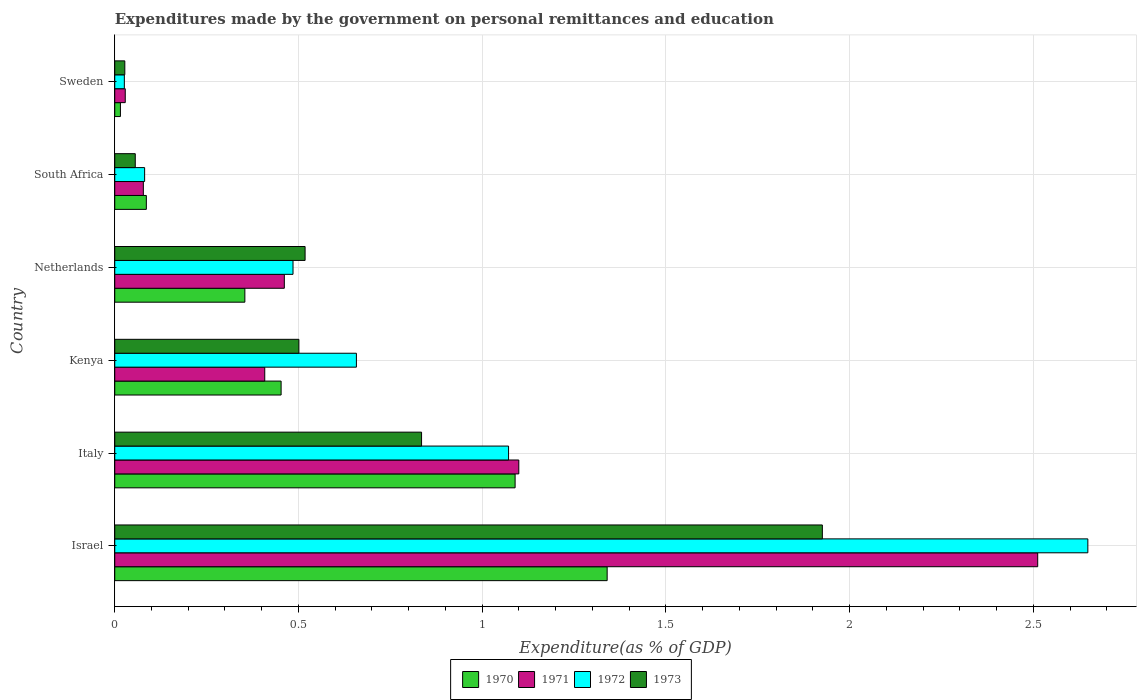How many different coloured bars are there?
Offer a very short reply. 4. Are the number of bars per tick equal to the number of legend labels?
Your answer should be very brief. Yes. Are the number of bars on each tick of the Y-axis equal?
Provide a short and direct response. Yes. How many bars are there on the 1st tick from the top?
Make the answer very short. 4. How many bars are there on the 3rd tick from the bottom?
Provide a short and direct response. 4. What is the label of the 6th group of bars from the top?
Give a very brief answer. Israel. In how many cases, is the number of bars for a given country not equal to the number of legend labels?
Keep it short and to the point. 0. What is the expenditures made by the government on personal remittances and education in 1970 in Italy?
Your answer should be very brief. 1.09. Across all countries, what is the maximum expenditures made by the government on personal remittances and education in 1973?
Provide a short and direct response. 1.93. Across all countries, what is the minimum expenditures made by the government on personal remittances and education in 1972?
Offer a terse response. 0.03. In which country was the expenditures made by the government on personal remittances and education in 1972 minimum?
Offer a terse response. Sweden. What is the total expenditures made by the government on personal remittances and education in 1971 in the graph?
Offer a terse response. 4.59. What is the difference between the expenditures made by the government on personal remittances and education in 1972 in Israel and that in Italy?
Make the answer very short. 1.58. What is the difference between the expenditures made by the government on personal remittances and education in 1970 in Sweden and the expenditures made by the government on personal remittances and education in 1973 in Netherlands?
Ensure brevity in your answer.  -0.5. What is the average expenditures made by the government on personal remittances and education in 1973 per country?
Offer a very short reply. 0.64. What is the difference between the expenditures made by the government on personal remittances and education in 1971 and expenditures made by the government on personal remittances and education in 1973 in Netherlands?
Your answer should be very brief. -0.06. What is the ratio of the expenditures made by the government on personal remittances and education in 1971 in Italy to that in Netherlands?
Ensure brevity in your answer.  2.38. What is the difference between the highest and the second highest expenditures made by the government on personal remittances and education in 1972?
Offer a terse response. 1.58. What is the difference between the highest and the lowest expenditures made by the government on personal remittances and education in 1972?
Provide a succinct answer. 2.62. In how many countries, is the expenditures made by the government on personal remittances and education in 1972 greater than the average expenditures made by the government on personal remittances and education in 1972 taken over all countries?
Keep it short and to the point. 2. Is the sum of the expenditures made by the government on personal remittances and education in 1972 in Israel and South Africa greater than the maximum expenditures made by the government on personal remittances and education in 1973 across all countries?
Offer a very short reply. Yes. What does the 1st bar from the top in Israel represents?
Offer a terse response. 1973. How many countries are there in the graph?
Your response must be concise. 6. Are the values on the major ticks of X-axis written in scientific E-notation?
Offer a terse response. No. Where does the legend appear in the graph?
Your answer should be compact. Bottom center. How many legend labels are there?
Give a very brief answer. 4. How are the legend labels stacked?
Your answer should be very brief. Horizontal. What is the title of the graph?
Ensure brevity in your answer.  Expenditures made by the government on personal remittances and education. Does "1998" appear as one of the legend labels in the graph?
Offer a very short reply. No. What is the label or title of the X-axis?
Ensure brevity in your answer.  Expenditure(as % of GDP). What is the Expenditure(as % of GDP) of 1970 in Israel?
Provide a succinct answer. 1.34. What is the Expenditure(as % of GDP) in 1971 in Israel?
Offer a terse response. 2.51. What is the Expenditure(as % of GDP) of 1972 in Israel?
Ensure brevity in your answer.  2.65. What is the Expenditure(as % of GDP) in 1973 in Israel?
Provide a succinct answer. 1.93. What is the Expenditure(as % of GDP) in 1970 in Italy?
Give a very brief answer. 1.09. What is the Expenditure(as % of GDP) of 1971 in Italy?
Make the answer very short. 1.1. What is the Expenditure(as % of GDP) of 1972 in Italy?
Offer a very short reply. 1.07. What is the Expenditure(as % of GDP) of 1973 in Italy?
Your answer should be compact. 0.84. What is the Expenditure(as % of GDP) in 1970 in Kenya?
Your response must be concise. 0.45. What is the Expenditure(as % of GDP) in 1971 in Kenya?
Ensure brevity in your answer.  0.41. What is the Expenditure(as % of GDP) of 1972 in Kenya?
Your answer should be compact. 0.66. What is the Expenditure(as % of GDP) of 1973 in Kenya?
Keep it short and to the point. 0.5. What is the Expenditure(as % of GDP) in 1970 in Netherlands?
Ensure brevity in your answer.  0.35. What is the Expenditure(as % of GDP) in 1971 in Netherlands?
Make the answer very short. 0.46. What is the Expenditure(as % of GDP) in 1972 in Netherlands?
Offer a terse response. 0.49. What is the Expenditure(as % of GDP) in 1973 in Netherlands?
Your response must be concise. 0.52. What is the Expenditure(as % of GDP) of 1970 in South Africa?
Offer a terse response. 0.09. What is the Expenditure(as % of GDP) of 1971 in South Africa?
Offer a very short reply. 0.08. What is the Expenditure(as % of GDP) of 1972 in South Africa?
Provide a short and direct response. 0.08. What is the Expenditure(as % of GDP) in 1973 in South Africa?
Keep it short and to the point. 0.06. What is the Expenditure(as % of GDP) of 1970 in Sweden?
Make the answer very short. 0.02. What is the Expenditure(as % of GDP) in 1971 in Sweden?
Your response must be concise. 0.03. What is the Expenditure(as % of GDP) of 1972 in Sweden?
Offer a terse response. 0.03. What is the Expenditure(as % of GDP) of 1973 in Sweden?
Give a very brief answer. 0.03. Across all countries, what is the maximum Expenditure(as % of GDP) in 1970?
Provide a short and direct response. 1.34. Across all countries, what is the maximum Expenditure(as % of GDP) of 1971?
Offer a terse response. 2.51. Across all countries, what is the maximum Expenditure(as % of GDP) of 1972?
Keep it short and to the point. 2.65. Across all countries, what is the maximum Expenditure(as % of GDP) of 1973?
Your answer should be very brief. 1.93. Across all countries, what is the minimum Expenditure(as % of GDP) in 1970?
Give a very brief answer. 0.02. Across all countries, what is the minimum Expenditure(as % of GDP) of 1971?
Give a very brief answer. 0.03. Across all countries, what is the minimum Expenditure(as % of GDP) of 1972?
Ensure brevity in your answer.  0.03. Across all countries, what is the minimum Expenditure(as % of GDP) in 1973?
Your answer should be compact. 0.03. What is the total Expenditure(as % of GDP) in 1970 in the graph?
Offer a very short reply. 3.34. What is the total Expenditure(as % of GDP) of 1971 in the graph?
Make the answer very short. 4.59. What is the total Expenditure(as % of GDP) in 1972 in the graph?
Your answer should be compact. 4.97. What is the total Expenditure(as % of GDP) in 1973 in the graph?
Your response must be concise. 3.86. What is the difference between the Expenditure(as % of GDP) in 1970 in Israel and that in Italy?
Provide a succinct answer. 0.25. What is the difference between the Expenditure(as % of GDP) in 1971 in Israel and that in Italy?
Offer a very short reply. 1.41. What is the difference between the Expenditure(as % of GDP) of 1972 in Israel and that in Italy?
Give a very brief answer. 1.58. What is the difference between the Expenditure(as % of GDP) in 1970 in Israel and that in Kenya?
Offer a very short reply. 0.89. What is the difference between the Expenditure(as % of GDP) in 1971 in Israel and that in Kenya?
Provide a short and direct response. 2.1. What is the difference between the Expenditure(as % of GDP) in 1972 in Israel and that in Kenya?
Make the answer very short. 1.99. What is the difference between the Expenditure(as % of GDP) in 1973 in Israel and that in Kenya?
Your response must be concise. 1.42. What is the difference between the Expenditure(as % of GDP) in 1970 in Israel and that in Netherlands?
Make the answer very short. 0.99. What is the difference between the Expenditure(as % of GDP) of 1971 in Israel and that in Netherlands?
Provide a succinct answer. 2.05. What is the difference between the Expenditure(as % of GDP) of 1972 in Israel and that in Netherlands?
Provide a succinct answer. 2.16. What is the difference between the Expenditure(as % of GDP) of 1973 in Israel and that in Netherlands?
Make the answer very short. 1.41. What is the difference between the Expenditure(as % of GDP) of 1970 in Israel and that in South Africa?
Ensure brevity in your answer.  1.25. What is the difference between the Expenditure(as % of GDP) of 1971 in Israel and that in South Africa?
Your response must be concise. 2.43. What is the difference between the Expenditure(as % of GDP) in 1972 in Israel and that in South Africa?
Provide a short and direct response. 2.57. What is the difference between the Expenditure(as % of GDP) of 1973 in Israel and that in South Africa?
Offer a very short reply. 1.87. What is the difference between the Expenditure(as % of GDP) of 1970 in Israel and that in Sweden?
Offer a terse response. 1.32. What is the difference between the Expenditure(as % of GDP) of 1971 in Israel and that in Sweden?
Offer a terse response. 2.48. What is the difference between the Expenditure(as % of GDP) of 1972 in Israel and that in Sweden?
Your answer should be very brief. 2.62. What is the difference between the Expenditure(as % of GDP) in 1973 in Israel and that in Sweden?
Provide a short and direct response. 1.9. What is the difference between the Expenditure(as % of GDP) in 1970 in Italy and that in Kenya?
Provide a short and direct response. 0.64. What is the difference between the Expenditure(as % of GDP) in 1971 in Italy and that in Kenya?
Your answer should be compact. 0.69. What is the difference between the Expenditure(as % of GDP) of 1972 in Italy and that in Kenya?
Provide a short and direct response. 0.41. What is the difference between the Expenditure(as % of GDP) in 1973 in Italy and that in Kenya?
Keep it short and to the point. 0.33. What is the difference between the Expenditure(as % of GDP) of 1970 in Italy and that in Netherlands?
Your answer should be very brief. 0.74. What is the difference between the Expenditure(as % of GDP) in 1971 in Italy and that in Netherlands?
Provide a succinct answer. 0.64. What is the difference between the Expenditure(as % of GDP) in 1972 in Italy and that in Netherlands?
Provide a succinct answer. 0.59. What is the difference between the Expenditure(as % of GDP) in 1973 in Italy and that in Netherlands?
Keep it short and to the point. 0.32. What is the difference between the Expenditure(as % of GDP) in 1971 in Italy and that in South Africa?
Give a very brief answer. 1.02. What is the difference between the Expenditure(as % of GDP) of 1972 in Italy and that in South Africa?
Your answer should be compact. 0.99. What is the difference between the Expenditure(as % of GDP) of 1973 in Italy and that in South Africa?
Your answer should be very brief. 0.78. What is the difference between the Expenditure(as % of GDP) in 1970 in Italy and that in Sweden?
Your answer should be very brief. 1.07. What is the difference between the Expenditure(as % of GDP) in 1971 in Italy and that in Sweden?
Provide a succinct answer. 1.07. What is the difference between the Expenditure(as % of GDP) of 1972 in Italy and that in Sweden?
Make the answer very short. 1.05. What is the difference between the Expenditure(as % of GDP) in 1973 in Italy and that in Sweden?
Offer a terse response. 0.81. What is the difference between the Expenditure(as % of GDP) of 1970 in Kenya and that in Netherlands?
Provide a short and direct response. 0.1. What is the difference between the Expenditure(as % of GDP) of 1971 in Kenya and that in Netherlands?
Your answer should be very brief. -0.05. What is the difference between the Expenditure(as % of GDP) of 1972 in Kenya and that in Netherlands?
Your response must be concise. 0.17. What is the difference between the Expenditure(as % of GDP) in 1973 in Kenya and that in Netherlands?
Provide a succinct answer. -0.02. What is the difference between the Expenditure(as % of GDP) in 1970 in Kenya and that in South Africa?
Provide a short and direct response. 0.37. What is the difference between the Expenditure(as % of GDP) in 1971 in Kenya and that in South Africa?
Your answer should be very brief. 0.33. What is the difference between the Expenditure(as % of GDP) of 1972 in Kenya and that in South Africa?
Provide a succinct answer. 0.58. What is the difference between the Expenditure(as % of GDP) of 1973 in Kenya and that in South Africa?
Provide a succinct answer. 0.45. What is the difference between the Expenditure(as % of GDP) of 1970 in Kenya and that in Sweden?
Provide a succinct answer. 0.44. What is the difference between the Expenditure(as % of GDP) of 1971 in Kenya and that in Sweden?
Offer a terse response. 0.38. What is the difference between the Expenditure(as % of GDP) in 1972 in Kenya and that in Sweden?
Offer a terse response. 0.63. What is the difference between the Expenditure(as % of GDP) in 1973 in Kenya and that in Sweden?
Provide a succinct answer. 0.47. What is the difference between the Expenditure(as % of GDP) in 1970 in Netherlands and that in South Africa?
Give a very brief answer. 0.27. What is the difference between the Expenditure(as % of GDP) in 1971 in Netherlands and that in South Africa?
Make the answer very short. 0.38. What is the difference between the Expenditure(as % of GDP) in 1972 in Netherlands and that in South Africa?
Provide a short and direct response. 0.4. What is the difference between the Expenditure(as % of GDP) of 1973 in Netherlands and that in South Africa?
Keep it short and to the point. 0.46. What is the difference between the Expenditure(as % of GDP) in 1970 in Netherlands and that in Sweden?
Your response must be concise. 0.34. What is the difference between the Expenditure(as % of GDP) of 1971 in Netherlands and that in Sweden?
Your response must be concise. 0.43. What is the difference between the Expenditure(as % of GDP) in 1972 in Netherlands and that in Sweden?
Make the answer very short. 0.46. What is the difference between the Expenditure(as % of GDP) in 1973 in Netherlands and that in Sweden?
Offer a terse response. 0.49. What is the difference between the Expenditure(as % of GDP) in 1970 in South Africa and that in Sweden?
Your answer should be very brief. 0.07. What is the difference between the Expenditure(as % of GDP) of 1971 in South Africa and that in Sweden?
Your answer should be very brief. 0.05. What is the difference between the Expenditure(as % of GDP) in 1972 in South Africa and that in Sweden?
Keep it short and to the point. 0.06. What is the difference between the Expenditure(as % of GDP) of 1973 in South Africa and that in Sweden?
Your answer should be very brief. 0.03. What is the difference between the Expenditure(as % of GDP) of 1970 in Israel and the Expenditure(as % of GDP) of 1971 in Italy?
Offer a very short reply. 0.24. What is the difference between the Expenditure(as % of GDP) in 1970 in Israel and the Expenditure(as % of GDP) in 1972 in Italy?
Make the answer very short. 0.27. What is the difference between the Expenditure(as % of GDP) in 1970 in Israel and the Expenditure(as % of GDP) in 1973 in Italy?
Provide a succinct answer. 0.51. What is the difference between the Expenditure(as % of GDP) of 1971 in Israel and the Expenditure(as % of GDP) of 1972 in Italy?
Your answer should be very brief. 1.44. What is the difference between the Expenditure(as % of GDP) in 1971 in Israel and the Expenditure(as % of GDP) in 1973 in Italy?
Your answer should be compact. 1.68. What is the difference between the Expenditure(as % of GDP) in 1972 in Israel and the Expenditure(as % of GDP) in 1973 in Italy?
Your answer should be very brief. 1.81. What is the difference between the Expenditure(as % of GDP) in 1970 in Israel and the Expenditure(as % of GDP) in 1971 in Kenya?
Provide a short and direct response. 0.93. What is the difference between the Expenditure(as % of GDP) of 1970 in Israel and the Expenditure(as % of GDP) of 1972 in Kenya?
Offer a terse response. 0.68. What is the difference between the Expenditure(as % of GDP) in 1970 in Israel and the Expenditure(as % of GDP) in 1973 in Kenya?
Offer a very short reply. 0.84. What is the difference between the Expenditure(as % of GDP) of 1971 in Israel and the Expenditure(as % of GDP) of 1972 in Kenya?
Provide a short and direct response. 1.85. What is the difference between the Expenditure(as % of GDP) of 1971 in Israel and the Expenditure(as % of GDP) of 1973 in Kenya?
Keep it short and to the point. 2.01. What is the difference between the Expenditure(as % of GDP) in 1972 in Israel and the Expenditure(as % of GDP) in 1973 in Kenya?
Your answer should be very brief. 2.15. What is the difference between the Expenditure(as % of GDP) of 1970 in Israel and the Expenditure(as % of GDP) of 1971 in Netherlands?
Your answer should be very brief. 0.88. What is the difference between the Expenditure(as % of GDP) of 1970 in Israel and the Expenditure(as % of GDP) of 1972 in Netherlands?
Your answer should be compact. 0.85. What is the difference between the Expenditure(as % of GDP) of 1970 in Israel and the Expenditure(as % of GDP) of 1973 in Netherlands?
Ensure brevity in your answer.  0.82. What is the difference between the Expenditure(as % of GDP) of 1971 in Israel and the Expenditure(as % of GDP) of 1972 in Netherlands?
Keep it short and to the point. 2.03. What is the difference between the Expenditure(as % of GDP) in 1971 in Israel and the Expenditure(as % of GDP) in 1973 in Netherlands?
Provide a succinct answer. 1.99. What is the difference between the Expenditure(as % of GDP) in 1972 in Israel and the Expenditure(as % of GDP) in 1973 in Netherlands?
Keep it short and to the point. 2.13. What is the difference between the Expenditure(as % of GDP) in 1970 in Israel and the Expenditure(as % of GDP) in 1971 in South Africa?
Ensure brevity in your answer.  1.26. What is the difference between the Expenditure(as % of GDP) of 1970 in Israel and the Expenditure(as % of GDP) of 1972 in South Africa?
Your answer should be very brief. 1.26. What is the difference between the Expenditure(as % of GDP) in 1970 in Israel and the Expenditure(as % of GDP) in 1973 in South Africa?
Your answer should be very brief. 1.28. What is the difference between the Expenditure(as % of GDP) in 1971 in Israel and the Expenditure(as % of GDP) in 1972 in South Africa?
Offer a terse response. 2.43. What is the difference between the Expenditure(as % of GDP) of 1971 in Israel and the Expenditure(as % of GDP) of 1973 in South Africa?
Make the answer very short. 2.46. What is the difference between the Expenditure(as % of GDP) in 1972 in Israel and the Expenditure(as % of GDP) in 1973 in South Africa?
Ensure brevity in your answer.  2.59. What is the difference between the Expenditure(as % of GDP) in 1970 in Israel and the Expenditure(as % of GDP) in 1971 in Sweden?
Your answer should be compact. 1.31. What is the difference between the Expenditure(as % of GDP) in 1970 in Israel and the Expenditure(as % of GDP) in 1972 in Sweden?
Your answer should be very brief. 1.31. What is the difference between the Expenditure(as % of GDP) in 1970 in Israel and the Expenditure(as % of GDP) in 1973 in Sweden?
Make the answer very short. 1.31. What is the difference between the Expenditure(as % of GDP) of 1971 in Israel and the Expenditure(as % of GDP) of 1972 in Sweden?
Offer a very short reply. 2.49. What is the difference between the Expenditure(as % of GDP) of 1971 in Israel and the Expenditure(as % of GDP) of 1973 in Sweden?
Your answer should be very brief. 2.48. What is the difference between the Expenditure(as % of GDP) of 1972 in Israel and the Expenditure(as % of GDP) of 1973 in Sweden?
Provide a short and direct response. 2.62. What is the difference between the Expenditure(as % of GDP) of 1970 in Italy and the Expenditure(as % of GDP) of 1971 in Kenya?
Your response must be concise. 0.68. What is the difference between the Expenditure(as % of GDP) in 1970 in Italy and the Expenditure(as % of GDP) in 1972 in Kenya?
Provide a short and direct response. 0.43. What is the difference between the Expenditure(as % of GDP) in 1970 in Italy and the Expenditure(as % of GDP) in 1973 in Kenya?
Ensure brevity in your answer.  0.59. What is the difference between the Expenditure(as % of GDP) in 1971 in Italy and the Expenditure(as % of GDP) in 1972 in Kenya?
Provide a succinct answer. 0.44. What is the difference between the Expenditure(as % of GDP) in 1971 in Italy and the Expenditure(as % of GDP) in 1973 in Kenya?
Give a very brief answer. 0.6. What is the difference between the Expenditure(as % of GDP) in 1972 in Italy and the Expenditure(as % of GDP) in 1973 in Kenya?
Provide a short and direct response. 0.57. What is the difference between the Expenditure(as % of GDP) in 1970 in Italy and the Expenditure(as % of GDP) in 1971 in Netherlands?
Your response must be concise. 0.63. What is the difference between the Expenditure(as % of GDP) in 1970 in Italy and the Expenditure(as % of GDP) in 1972 in Netherlands?
Give a very brief answer. 0.6. What is the difference between the Expenditure(as % of GDP) of 1970 in Italy and the Expenditure(as % of GDP) of 1973 in Netherlands?
Keep it short and to the point. 0.57. What is the difference between the Expenditure(as % of GDP) of 1971 in Italy and the Expenditure(as % of GDP) of 1972 in Netherlands?
Provide a succinct answer. 0.61. What is the difference between the Expenditure(as % of GDP) in 1971 in Italy and the Expenditure(as % of GDP) in 1973 in Netherlands?
Make the answer very short. 0.58. What is the difference between the Expenditure(as % of GDP) of 1972 in Italy and the Expenditure(as % of GDP) of 1973 in Netherlands?
Your answer should be very brief. 0.55. What is the difference between the Expenditure(as % of GDP) of 1970 in Italy and the Expenditure(as % of GDP) of 1971 in South Africa?
Provide a succinct answer. 1.01. What is the difference between the Expenditure(as % of GDP) in 1970 in Italy and the Expenditure(as % of GDP) in 1972 in South Africa?
Keep it short and to the point. 1.01. What is the difference between the Expenditure(as % of GDP) of 1970 in Italy and the Expenditure(as % of GDP) of 1973 in South Africa?
Offer a terse response. 1.03. What is the difference between the Expenditure(as % of GDP) of 1971 in Italy and the Expenditure(as % of GDP) of 1972 in South Africa?
Provide a succinct answer. 1.02. What is the difference between the Expenditure(as % of GDP) of 1971 in Italy and the Expenditure(as % of GDP) of 1973 in South Africa?
Offer a terse response. 1.04. What is the difference between the Expenditure(as % of GDP) in 1970 in Italy and the Expenditure(as % of GDP) in 1971 in Sweden?
Give a very brief answer. 1.06. What is the difference between the Expenditure(as % of GDP) of 1970 in Italy and the Expenditure(as % of GDP) of 1972 in Sweden?
Give a very brief answer. 1.06. What is the difference between the Expenditure(as % of GDP) in 1970 in Italy and the Expenditure(as % of GDP) in 1973 in Sweden?
Keep it short and to the point. 1.06. What is the difference between the Expenditure(as % of GDP) in 1971 in Italy and the Expenditure(as % of GDP) in 1972 in Sweden?
Your response must be concise. 1.07. What is the difference between the Expenditure(as % of GDP) in 1971 in Italy and the Expenditure(as % of GDP) in 1973 in Sweden?
Keep it short and to the point. 1.07. What is the difference between the Expenditure(as % of GDP) of 1972 in Italy and the Expenditure(as % of GDP) of 1973 in Sweden?
Make the answer very short. 1.04. What is the difference between the Expenditure(as % of GDP) of 1970 in Kenya and the Expenditure(as % of GDP) of 1971 in Netherlands?
Keep it short and to the point. -0.01. What is the difference between the Expenditure(as % of GDP) of 1970 in Kenya and the Expenditure(as % of GDP) of 1972 in Netherlands?
Offer a very short reply. -0.03. What is the difference between the Expenditure(as % of GDP) of 1970 in Kenya and the Expenditure(as % of GDP) of 1973 in Netherlands?
Offer a very short reply. -0.07. What is the difference between the Expenditure(as % of GDP) in 1971 in Kenya and the Expenditure(as % of GDP) in 1972 in Netherlands?
Ensure brevity in your answer.  -0.08. What is the difference between the Expenditure(as % of GDP) of 1971 in Kenya and the Expenditure(as % of GDP) of 1973 in Netherlands?
Provide a succinct answer. -0.11. What is the difference between the Expenditure(as % of GDP) of 1972 in Kenya and the Expenditure(as % of GDP) of 1973 in Netherlands?
Give a very brief answer. 0.14. What is the difference between the Expenditure(as % of GDP) of 1970 in Kenya and the Expenditure(as % of GDP) of 1972 in South Africa?
Ensure brevity in your answer.  0.37. What is the difference between the Expenditure(as % of GDP) of 1970 in Kenya and the Expenditure(as % of GDP) of 1973 in South Africa?
Your answer should be compact. 0.4. What is the difference between the Expenditure(as % of GDP) of 1971 in Kenya and the Expenditure(as % of GDP) of 1972 in South Africa?
Keep it short and to the point. 0.33. What is the difference between the Expenditure(as % of GDP) in 1971 in Kenya and the Expenditure(as % of GDP) in 1973 in South Africa?
Provide a succinct answer. 0.35. What is the difference between the Expenditure(as % of GDP) of 1972 in Kenya and the Expenditure(as % of GDP) of 1973 in South Africa?
Keep it short and to the point. 0.6. What is the difference between the Expenditure(as % of GDP) of 1970 in Kenya and the Expenditure(as % of GDP) of 1971 in Sweden?
Offer a terse response. 0.42. What is the difference between the Expenditure(as % of GDP) of 1970 in Kenya and the Expenditure(as % of GDP) of 1972 in Sweden?
Make the answer very short. 0.43. What is the difference between the Expenditure(as % of GDP) in 1970 in Kenya and the Expenditure(as % of GDP) in 1973 in Sweden?
Offer a very short reply. 0.43. What is the difference between the Expenditure(as % of GDP) in 1971 in Kenya and the Expenditure(as % of GDP) in 1972 in Sweden?
Ensure brevity in your answer.  0.38. What is the difference between the Expenditure(as % of GDP) in 1971 in Kenya and the Expenditure(as % of GDP) in 1973 in Sweden?
Your response must be concise. 0.38. What is the difference between the Expenditure(as % of GDP) in 1972 in Kenya and the Expenditure(as % of GDP) in 1973 in Sweden?
Offer a very short reply. 0.63. What is the difference between the Expenditure(as % of GDP) of 1970 in Netherlands and the Expenditure(as % of GDP) of 1971 in South Africa?
Provide a short and direct response. 0.28. What is the difference between the Expenditure(as % of GDP) of 1970 in Netherlands and the Expenditure(as % of GDP) of 1972 in South Africa?
Keep it short and to the point. 0.27. What is the difference between the Expenditure(as % of GDP) in 1970 in Netherlands and the Expenditure(as % of GDP) in 1973 in South Africa?
Make the answer very short. 0.3. What is the difference between the Expenditure(as % of GDP) in 1971 in Netherlands and the Expenditure(as % of GDP) in 1972 in South Africa?
Provide a short and direct response. 0.38. What is the difference between the Expenditure(as % of GDP) of 1971 in Netherlands and the Expenditure(as % of GDP) of 1973 in South Africa?
Offer a terse response. 0.41. What is the difference between the Expenditure(as % of GDP) in 1972 in Netherlands and the Expenditure(as % of GDP) in 1973 in South Africa?
Give a very brief answer. 0.43. What is the difference between the Expenditure(as % of GDP) of 1970 in Netherlands and the Expenditure(as % of GDP) of 1971 in Sweden?
Provide a succinct answer. 0.33. What is the difference between the Expenditure(as % of GDP) in 1970 in Netherlands and the Expenditure(as % of GDP) in 1972 in Sweden?
Give a very brief answer. 0.33. What is the difference between the Expenditure(as % of GDP) in 1970 in Netherlands and the Expenditure(as % of GDP) in 1973 in Sweden?
Your answer should be very brief. 0.33. What is the difference between the Expenditure(as % of GDP) of 1971 in Netherlands and the Expenditure(as % of GDP) of 1972 in Sweden?
Make the answer very short. 0.44. What is the difference between the Expenditure(as % of GDP) of 1971 in Netherlands and the Expenditure(as % of GDP) of 1973 in Sweden?
Ensure brevity in your answer.  0.43. What is the difference between the Expenditure(as % of GDP) in 1972 in Netherlands and the Expenditure(as % of GDP) in 1973 in Sweden?
Your answer should be compact. 0.46. What is the difference between the Expenditure(as % of GDP) in 1970 in South Africa and the Expenditure(as % of GDP) in 1971 in Sweden?
Your answer should be very brief. 0.06. What is the difference between the Expenditure(as % of GDP) of 1970 in South Africa and the Expenditure(as % of GDP) of 1972 in Sweden?
Provide a short and direct response. 0.06. What is the difference between the Expenditure(as % of GDP) in 1970 in South Africa and the Expenditure(as % of GDP) in 1973 in Sweden?
Ensure brevity in your answer.  0.06. What is the difference between the Expenditure(as % of GDP) in 1971 in South Africa and the Expenditure(as % of GDP) in 1972 in Sweden?
Provide a short and direct response. 0.05. What is the difference between the Expenditure(as % of GDP) of 1971 in South Africa and the Expenditure(as % of GDP) of 1973 in Sweden?
Give a very brief answer. 0.05. What is the difference between the Expenditure(as % of GDP) in 1972 in South Africa and the Expenditure(as % of GDP) in 1973 in Sweden?
Keep it short and to the point. 0.05. What is the average Expenditure(as % of GDP) of 1970 per country?
Your answer should be compact. 0.56. What is the average Expenditure(as % of GDP) of 1971 per country?
Provide a succinct answer. 0.76. What is the average Expenditure(as % of GDP) of 1972 per country?
Ensure brevity in your answer.  0.83. What is the average Expenditure(as % of GDP) of 1973 per country?
Your response must be concise. 0.64. What is the difference between the Expenditure(as % of GDP) of 1970 and Expenditure(as % of GDP) of 1971 in Israel?
Keep it short and to the point. -1.17. What is the difference between the Expenditure(as % of GDP) of 1970 and Expenditure(as % of GDP) of 1972 in Israel?
Provide a succinct answer. -1.31. What is the difference between the Expenditure(as % of GDP) of 1970 and Expenditure(as % of GDP) of 1973 in Israel?
Give a very brief answer. -0.59. What is the difference between the Expenditure(as % of GDP) in 1971 and Expenditure(as % of GDP) in 1972 in Israel?
Your answer should be very brief. -0.14. What is the difference between the Expenditure(as % of GDP) of 1971 and Expenditure(as % of GDP) of 1973 in Israel?
Your answer should be very brief. 0.59. What is the difference between the Expenditure(as % of GDP) in 1972 and Expenditure(as % of GDP) in 1973 in Israel?
Give a very brief answer. 0.72. What is the difference between the Expenditure(as % of GDP) of 1970 and Expenditure(as % of GDP) of 1971 in Italy?
Provide a succinct answer. -0.01. What is the difference between the Expenditure(as % of GDP) of 1970 and Expenditure(as % of GDP) of 1972 in Italy?
Offer a terse response. 0.02. What is the difference between the Expenditure(as % of GDP) in 1970 and Expenditure(as % of GDP) in 1973 in Italy?
Offer a terse response. 0.25. What is the difference between the Expenditure(as % of GDP) of 1971 and Expenditure(as % of GDP) of 1972 in Italy?
Your answer should be very brief. 0.03. What is the difference between the Expenditure(as % of GDP) in 1971 and Expenditure(as % of GDP) in 1973 in Italy?
Provide a short and direct response. 0.26. What is the difference between the Expenditure(as % of GDP) of 1972 and Expenditure(as % of GDP) of 1973 in Italy?
Your answer should be compact. 0.24. What is the difference between the Expenditure(as % of GDP) of 1970 and Expenditure(as % of GDP) of 1971 in Kenya?
Your response must be concise. 0.04. What is the difference between the Expenditure(as % of GDP) of 1970 and Expenditure(as % of GDP) of 1972 in Kenya?
Provide a short and direct response. -0.2. What is the difference between the Expenditure(as % of GDP) in 1970 and Expenditure(as % of GDP) in 1973 in Kenya?
Provide a short and direct response. -0.05. What is the difference between the Expenditure(as % of GDP) of 1971 and Expenditure(as % of GDP) of 1972 in Kenya?
Offer a very short reply. -0.25. What is the difference between the Expenditure(as % of GDP) of 1971 and Expenditure(as % of GDP) of 1973 in Kenya?
Offer a very short reply. -0.09. What is the difference between the Expenditure(as % of GDP) of 1972 and Expenditure(as % of GDP) of 1973 in Kenya?
Provide a short and direct response. 0.16. What is the difference between the Expenditure(as % of GDP) in 1970 and Expenditure(as % of GDP) in 1971 in Netherlands?
Your answer should be compact. -0.11. What is the difference between the Expenditure(as % of GDP) of 1970 and Expenditure(as % of GDP) of 1972 in Netherlands?
Offer a very short reply. -0.13. What is the difference between the Expenditure(as % of GDP) of 1970 and Expenditure(as % of GDP) of 1973 in Netherlands?
Provide a succinct answer. -0.16. What is the difference between the Expenditure(as % of GDP) in 1971 and Expenditure(as % of GDP) in 1972 in Netherlands?
Offer a very short reply. -0.02. What is the difference between the Expenditure(as % of GDP) in 1971 and Expenditure(as % of GDP) in 1973 in Netherlands?
Provide a short and direct response. -0.06. What is the difference between the Expenditure(as % of GDP) of 1972 and Expenditure(as % of GDP) of 1973 in Netherlands?
Your response must be concise. -0.03. What is the difference between the Expenditure(as % of GDP) in 1970 and Expenditure(as % of GDP) in 1971 in South Africa?
Make the answer very short. 0.01. What is the difference between the Expenditure(as % of GDP) of 1970 and Expenditure(as % of GDP) of 1972 in South Africa?
Offer a very short reply. 0. What is the difference between the Expenditure(as % of GDP) of 1970 and Expenditure(as % of GDP) of 1973 in South Africa?
Offer a very short reply. 0.03. What is the difference between the Expenditure(as % of GDP) in 1971 and Expenditure(as % of GDP) in 1972 in South Africa?
Give a very brief answer. -0. What is the difference between the Expenditure(as % of GDP) in 1971 and Expenditure(as % of GDP) in 1973 in South Africa?
Ensure brevity in your answer.  0.02. What is the difference between the Expenditure(as % of GDP) in 1972 and Expenditure(as % of GDP) in 1973 in South Africa?
Keep it short and to the point. 0.03. What is the difference between the Expenditure(as % of GDP) of 1970 and Expenditure(as % of GDP) of 1971 in Sweden?
Your answer should be very brief. -0.01. What is the difference between the Expenditure(as % of GDP) of 1970 and Expenditure(as % of GDP) of 1972 in Sweden?
Your answer should be compact. -0.01. What is the difference between the Expenditure(as % of GDP) of 1970 and Expenditure(as % of GDP) of 1973 in Sweden?
Make the answer very short. -0.01. What is the difference between the Expenditure(as % of GDP) in 1971 and Expenditure(as % of GDP) in 1972 in Sweden?
Provide a short and direct response. 0. What is the difference between the Expenditure(as % of GDP) in 1971 and Expenditure(as % of GDP) in 1973 in Sweden?
Keep it short and to the point. 0. What is the difference between the Expenditure(as % of GDP) of 1972 and Expenditure(as % of GDP) of 1973 in Sweden?
Your answer should be compact. -0. What is the ratio of the Expenditure(as % of GDP) of 1970 in Israel to that in Italy?
Offer a very short reply. 1.23. What is the ratio of the Expenditure(as % of GDP) in 1971 in Israel to that in Italy?
Your response must be concise. 2.28. What is the ratio of the Expenditure(as % of GDP) in 1972 in Israel to that in Italy?
Offer a very short reply. 2.47. What is the ratio of the Expenditure(as % of GDP) in 1973 in Israel to that in Italy?
Offer a terse response. 2.31. What is the ratio of the Expenditure(as % of GDP) in 1970 in Israel to that in Kenya?
Give a very brief answer. 2.96. What is the ratio of the Expenditure(as % of GDP) of 1971 in Israel to that in Kenya?
Provide a succinct answer. 6.15. What is the ratio of the Expenditure(as % of GDP) in 1972 in Israel to that in Kenya?
Keep it short and to the point. 4.03. What is the ratio of the Expenditure(as % of GDP) of 1973 in Israel to that in Kenya?
Your response must be concise. 3.84. What is the ratio of the Expenditure(as % of GDP) in 1970 in Israel to that in Netherlands?
Your response must be concise. 3.78. What is the ratio of the Expenditure(as % of GDP) in 1971 in Israel to that in Netherlands?
Make the answer very short. 5.44. What is the ratio of the Expenditure(as % of GDP) of 1972 in Israel to that in Netherlands?
Keep it short and to the point. 5.46. What is the ratio of the Expenditure(as % of GDP) of 1973 in Israel to that in Netherlands?
Your answer should be very brief. 3.72. What is the ratio of the Expenditure(as % of GDP) in 1970 in Israel to that in South Africa?
Your answer should be very brief. 15.58. What is the ratio of the Expenditure(as % of GDP) of 1971 in Israel to that in South Africa?
Your response must be concise. 32.29. What is the ratio of the Expenditure(as % of GDP) in 1972 in Israel to that in South Africa?
Offer a very short reply. 32.58. What is the ratio of the Expenditure(as % of GDP) of 1973 in Israel to that in South Africa?
Ensure brevity in your answer.  34.5. What is the ratio of the Expenditure(as % of GDP) of 1970 in Israel to that in Sweden?
Your answer should be compact. 86.79. What is the ratio of the Expenditure(as % of GDP) of 1971 in Israel to that in Sweden?
Offer a very short reply. 87.95. What is the ratio of the Expenditure(as % of GDP) of 1972 in Israel to that in Sweden?
Make the answer very short. 101.46. What is the ratio of the Expenditure(as % of GDP) in 1973 in Israel to that in Sweden?
Offer a terse response. 70.37. What is the ratio of the Expenditure(as % of GDP) in 1970 in Italy to that in Kenya?
Ensure brevity in your answer.  2.41. What is the ratio of the Expenditure(as % of GDP) of 1971 in Italy to that in Kenya?
Make the answer very short. 2.69. What is the ratio of the Expenditure(as % of GDP) in 1972 in Italy to that in Kenya?
Your response must be concise. 1.63. What is the ratio of the Expenditure(as % of GDP) in 1973 in Italy to that in Kenya?
Your answer should be very brief. 1.67. What is the ratio of the Expenditure(as % of GDP) of 1970 in Italy to that in Netherlands?
Your answer should be very brief. 3.08. What is the ratio of the Expenditure(as % of GDP) of 1971 in Italy to that in Netherlands?
Ensure brevity in your answer.  2.38. What is the ratio of the Expenditure(as % of GDP) of 1972 in Italy to that in Netherlands?
Offer a very short reply. 2.21. What is the ratio of the Expenditure(as % of GDP) in 1973 in Italy to that in Netherlands?
Provide a succinct answer. 1.61. What is the ratio of the Expenditure(as % of GDP) in 1970 in Italy to that in South Africa?
Offer a very short reply. 12.67. What is the ratio of the Expenditure(as % of GDP) of 1971 in Italy to that in South Africa?
Give a very brief answer. 14.13. What is the ratio of the Expenditure(as % of GDP) in 1972 in Italy to that in South Africa?
Provide a short and direct response. 13.18. What is the ratio of the Expenditure(as % of GDP) of 1973 in Italy to that in South Africa?
Offer a very short reply. 14.96. What is the ratio of the Expenditure(as % of GDP) of 1970 in Italy to that in Sweden?
Your answer should be very brief. 70.57. What is the ratio of the Expenditure(as % of GDP) of 1971 in Italy to that in Sweden?
Ensure brevity in your answer.  38.5. What is the ratio of the Expenditure(as % of GDP) in 1972 in Italy to that in Sweden?
Give a very brief answer. 41.06. What is the ratio of the Expenditure(as % of GDP) in 1973 in Italy to that in Sweden?
Your answer should be very brief. 30.51. What is the ratio of the Expenditure(as % of GDP) of 1970 in Kenya to that in Netherlands?
Your response must be concise. 1.28. What is the ratio of the Expenditure(as % of GDP) of 1971 in Kenya to that in Netherlands?
Make the answer very short. 0.88. What is the ratio of the Expenditure(as % of GDP) of 1972 in Kenya to that in Netherlands?
Provide a short and direct response. 1.36. What is the ratio of the Expenditure(as % of GDP) of 1973 in Kenya to that in Netherlands?
Your response must be concise. 0.97. What is the ratio of the Expenditure(as % of GDP) in 1970 in Kenya to that in South Africa?
Provide a short and direct response. 5.26. What is the ratio of the Expenditure(as % of GDP) of 1971 in Kenya to that in South Africa?
Give a very brief answer. 5.25. What is the ratio of the Expenditure(as % of GDP) in 1972 in Kenya to that in South Africa?
Keep it short and to the point. 8.09. What is the ratio of the Expenditure(as % of GDP) of 1973 in Kenya to that in South Africa?
Ensure brevity in your answer.  8.98. What is the ratio of the Expenditure(as % of GDP) of 1970 in Kenya to that in Sweden?
Keep it short and to the point. 29.32. What is the ratio of the Expenditure(as % of GDP) in 1971 in Kenya to that in Sweden?
Your answer should be very brief. 14.29. What is the ratio of the Expenditure(as % of GDP) of 1972 in Kenya to that in Sweden?
Provide a short and direct response. 25.2. What is the ratio of the Expenditure(as % of GDP) in 1973 in Kenya to that in Sweden?
Offer a terse response. 18.31. What is the ratio of the Expenditure(as % of GDP) in 1970 in Netherlands to that in South Africa?
Ensure brevity in your answer.  4.12. What is the ratio of the Expenditure(as % of GDP) of 1971 in Netherlands to that in South Africa?
Give a very brief answer. 5.93. What is the ratio of the Expenditure(as % of GDP) in 1972 in Netherlands to that in South Africa?
Offer a terse response. 5.97. What is the ratio of the Expenditure(as % of GDP) of 1973 in Netherlands to that in South Africa?
Offer a terse response. 9.28. What is the ratio of the Expenditure(as % of GDP) of 1970 in Netherlands to that in Sweden?
Keep it short and to the point. 22.93. What is the ratio of the Expenditure(as % of GDP) of 1971 in Netherlands to that in Sweden?
Offer a very short reply. 16.16. What is the ratio of the Expenditure(as % of GDP) in 1972 in Netherlands to that in Sweden?
Give a very brief answer. 18.59. What is the ratio of the Expenditure(as % of GDP) of 1973 in Netherlands to that in Sweden?
Your answer should be compact. 18.93. What is the ratio of the Expenditure(as % of GDP) in 1970 in South Africa to that in Sweden?
Offer a very short reply. 5.57. What is the ratio of the Expenditure(as % of GDP) in 1971 in South Africa to that in Sweden?
Your answer should be compact. 2.72. What is the ratio of the Expenditure(as % of GDP) in 1972 in South Africa to that in Sweden?
Make the answer very short. 3.11. What is the ratio of the Expenditure(as % of GDP) of 1973 in South Africa to that in Sweden?
Ensure brevity in your answer.  2.04. What is the difference between the highest and the second highest Expenditure(as % of GDP) in 1970?
Offer a very short reply. 0.25. What is the difference between the highest and the second highest Expenditure(as % of GDP) in 1971?
Give a very brief answer. 1.41. What is the difference between the highest and the second highest Expenditure(as % of GDP) of 1972?
Offer a terse response. 1.58. What is the difference between the highest and the second highest Expenditure(as % of GDP) in 1973?
Offer a very short reply. 1.09. What is the difference between the highest and the lowest Expenditure(as % of GDP) of 1970?
Keep it short and to the point. 1.32. What is the difference between the highest and the lowest Expenditure(as % of GDP) in 1971?
Keep it short and to the point. 2.48. What is the difference between the highest and the lowest Expenditure(as % of GDP) in 1972?
Your response must be concise. 2.62. What is the difference between the highest and the lowest Expenditure(as % of GDP) of 1973?
Ensure brevity in your answer.  1.9. 